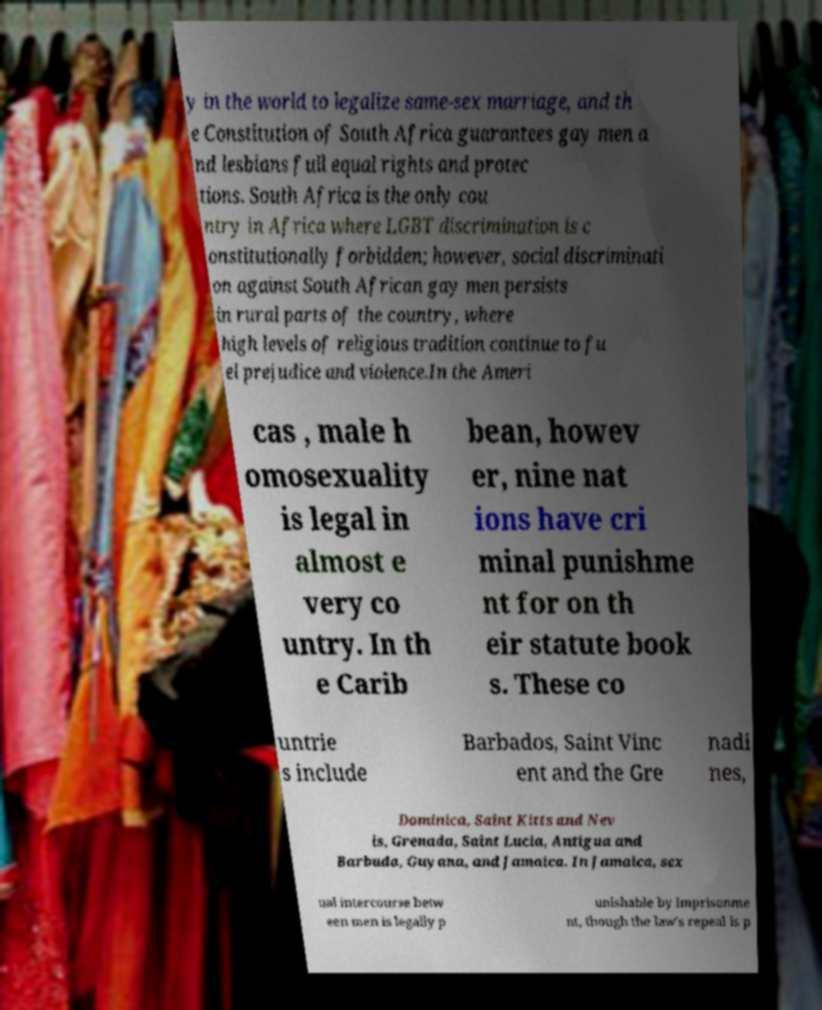There's text embedded in this image that I need extracted. Can you transcribe it verbatim? y in the world to legalize same-sex marriage, and th e Constitution of South Africa guarantees gay men a nd lesbians full equal rights and protec tions. South Africa is the only cou ntry in Africa where LGBT discrimination is c onstitutionally forbidden; however, social discriminati on against South African gay men persists in rural parts of the country, where high levels of religious tradition continue to fu el prejudice and violence.In the Ameri cas , male h omosexuality is legal in almost e very co untry. In th e Carib bean, howev er, nine nat ions have cri minal punishme nt for on th eir statute book s. These co untrie s include Barbados, Saint Vinc ent and the Gre nadi nes, Dominica, Saint Kitts and Nev is, Grenada, Saint Lucia, Antigua and Barbuda, Guyana, and Jamaica. In Jamaica, sex ual intercourse betw een men is legally p unishable by imprisonme nt, though the law's repeal is p 